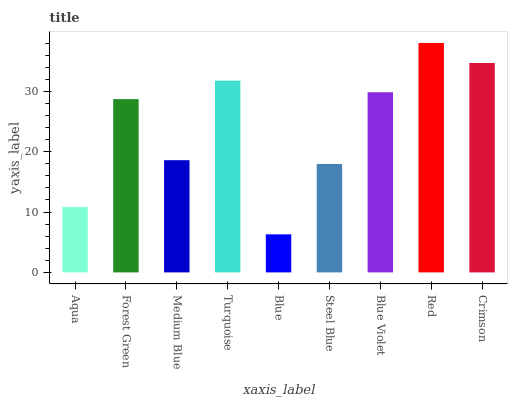Is Blue the minimum?
Answer yes or no. Yes. Is Red the maximum?
Answer yes or no. Yes. Is Forest Green the minimum?
Answer yes or no. No. Is Forest Green the maximum?
Answer yes or no. No. Is Forest Green greater than Aqua?
Answer yes or no. Yes. Is Aqua less than Forest Green?
Answer yes or no. Yes. Is Aqua greater than Forest Green?
Answer yes or no. No. Is Forest Green less than Aqua?
Answer yes or no. No. Is Forest Green the high median?
Answer yes or no. Yes. Is Forest Green the low median?
Answer yes or no. Yes. Is Red the high median?
Answer yes or no. No. Is Steel Blue the low median?
Answer yes or no. No. 